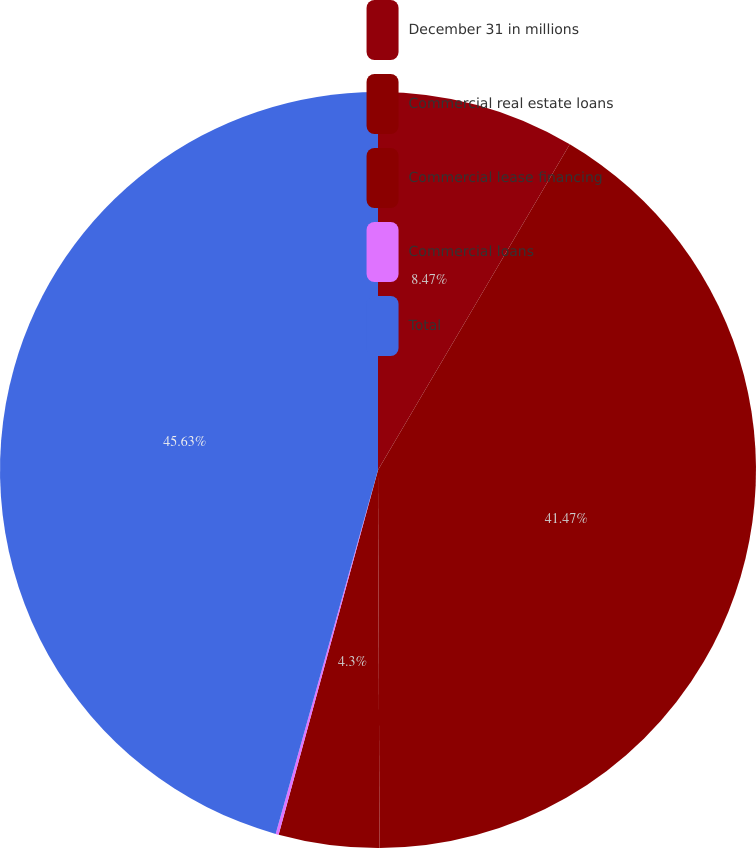Convert chart to OTSL. <chart><loc_0><loc_0><loc_500><loc_500><pie_chart><fcel>December 31 in millions<fcel>Commercial real estate loans<fcel>Commercial lease financing<fcel>Commercial loans<fcel>Total<nl><fcel>8.47%<fcel>41.47%<fcel>4.3%<fcel>0.13%<fcel>45.64%<nl></chart> 